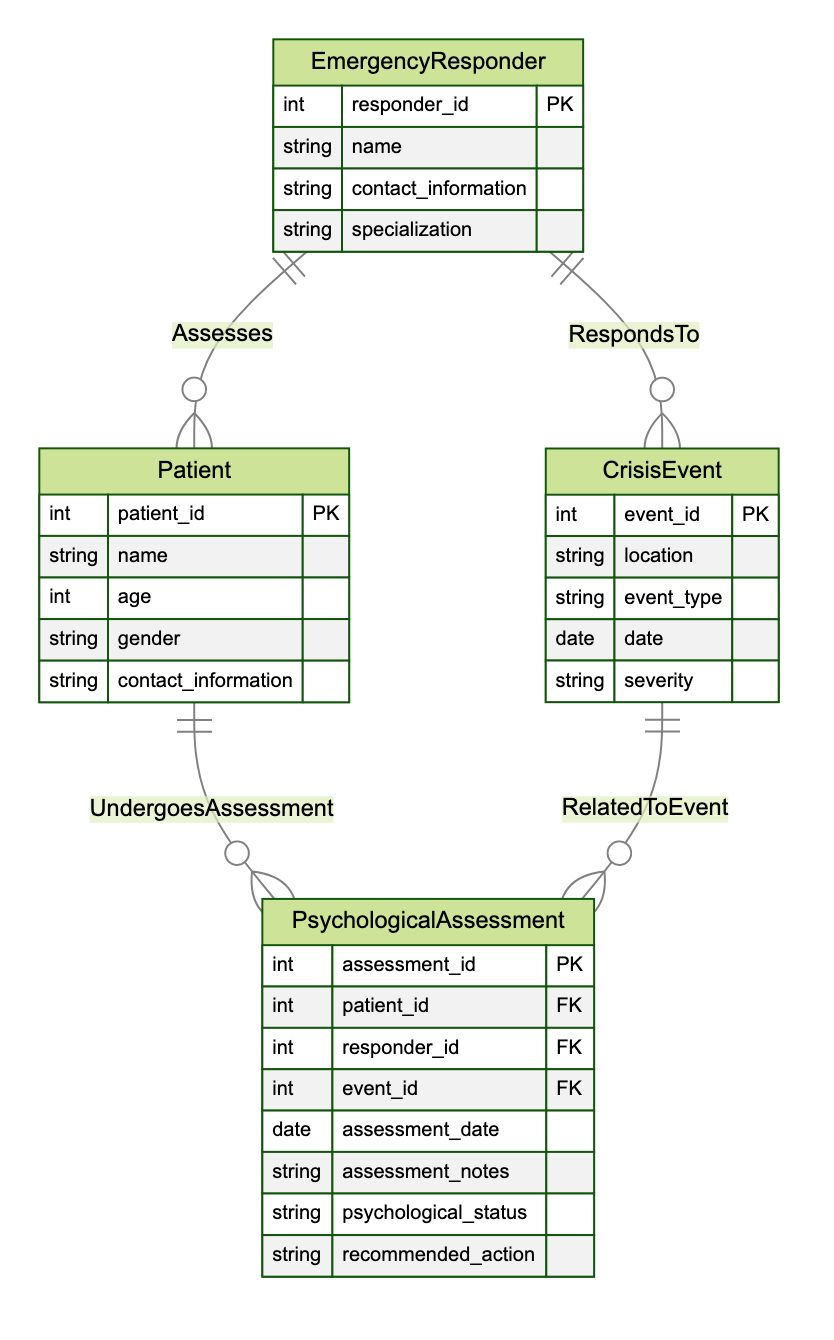What is the primary key of the Emergency Responder entity? The primary key for the Emergency Responder entity is identified in the diagram as 'responder_id'. This is the unique identifier for each emergency responder.
Answer: responder_id How many entities are represented in the diagram? By reviewing the diagram, I count a total of four entities: Emergency Responder, Patient, Crisis Event, and Psychological Assessment.
Answer: 4 What is the cardinality between Emergency Responder and Crisis Event? The 'RespondsTo' relationship between Emergency Responder and Crisis Event is described as many_to_many, indicating that a single responder can respond to multiple events, and each event can have multiple responders.
Answer: many_to_many Which entity undergoes a psychological assessment? The arrow connecting Patient and Psychological Assessment indicates that the Patient undergoes an assessment, indicated by the 'UndergoesAssessment' relationship.
Answer: Patient What relationship connects Psychological Assessment and Crisis Event? The relationship that connects Psychological Assessment to Crisis Event is called 'RelatedToEvent'. This indicates that each psychological assessment is associated with a particular crisis event.
Answer: RelatedToEvent How many attributes does the Psychological Assessment entity have? The Psychological Assessment entity is represented with eight attributes: assessment_id, patient_id, responder_id, event_id, assessment_date, assessment_notes, psychological_status, and recommended_action.
Answer: 8 What is the foreign key in the Psychological Assessment entity that relates to the Patient entity? The foreign key in the Psychological Assessment that relates to the Patient entity is 'patient_id'. It links the assessment specifically to a patient.
Answer: patient_id Which entity has the 'name' attribute? Both Emergency Responder and Patient entities have the 'name' attribute, representing the names of responders and patients, respectively.
Answer: Emergency Responder, Patient What type of relationship exists between Patient and Psychological Assessment? The relationship is termed 'UndergoesAssessment', showing a one_to_many relationship where one patient can have multiple assessments recorded.
Answer: one_to_many What is the primary key of the Psychological Assessment entity? The primary key for the Psychological Assessment entity is noted as 'assessment_id', serving to uniquely identify each assessment.
Answer: assessment_id 